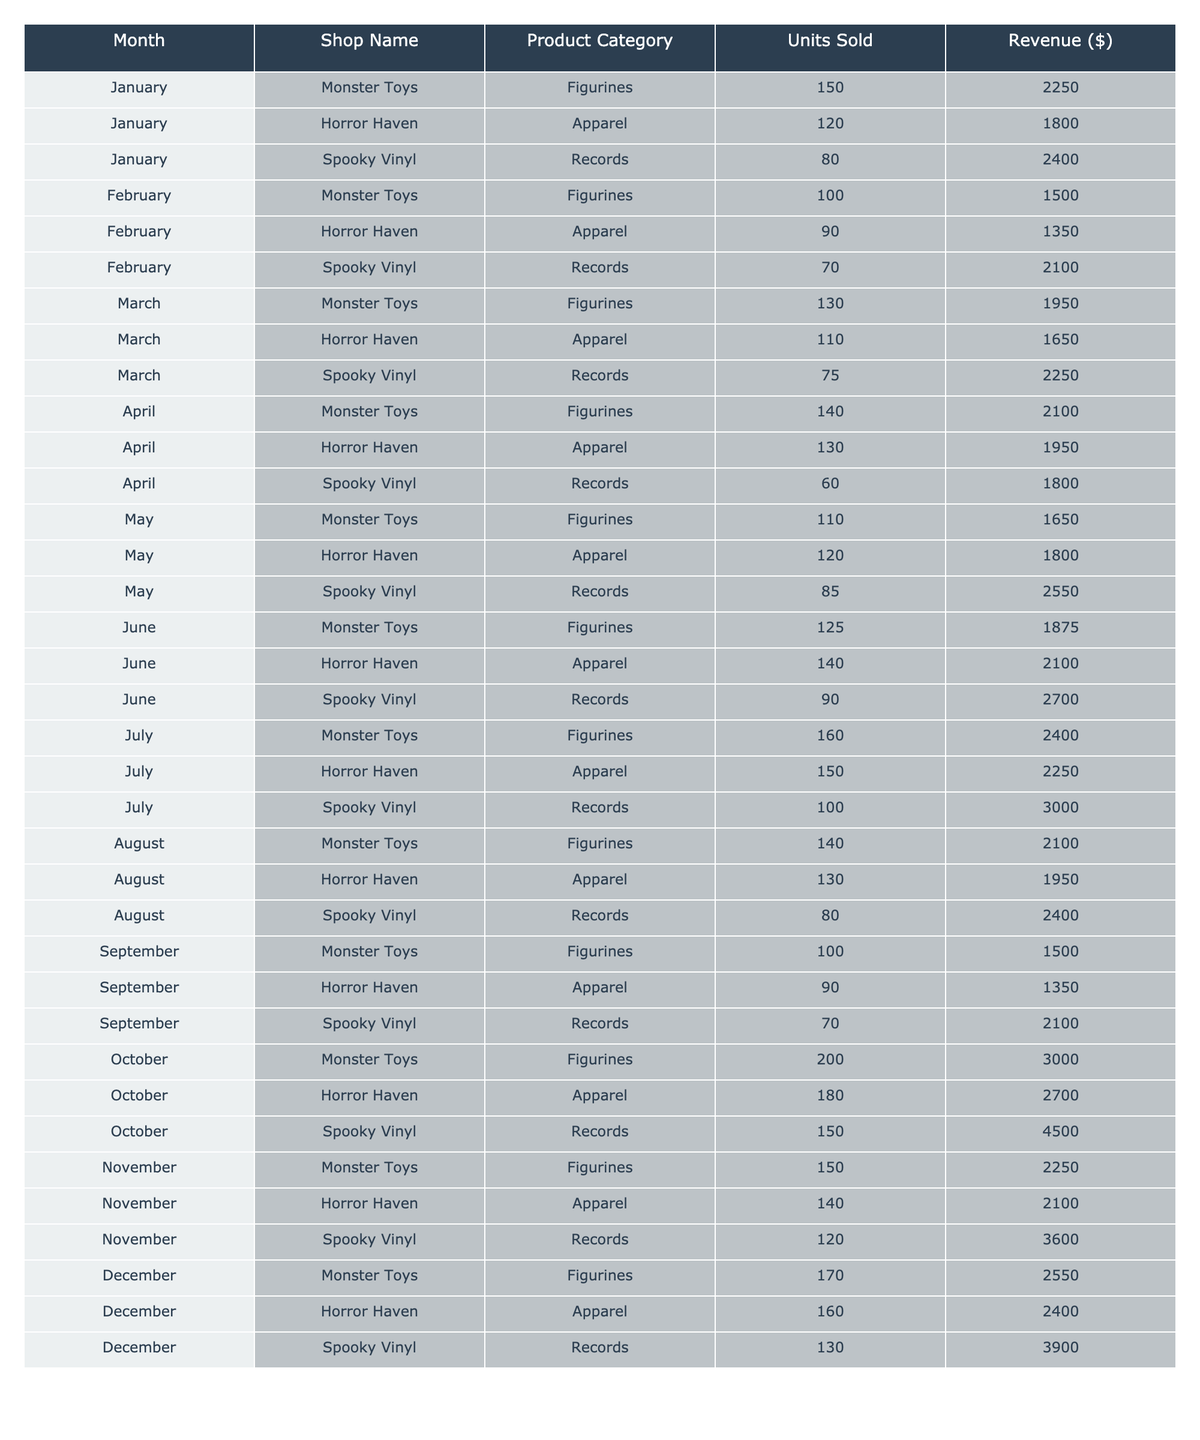What month had the highest sales revenue for Horror Haven? In October, Horror Haven sold 180 units of apparel for $2700, which is the highest revenue compared to other months.
Answer: October Which product category sold the most units in July? In July, Monster Toys sold 160 figurines, which is the highest number of units sold for any product category that month.
Answer: Figurines What was the total revenue generated by Spooky Vinyl in December? In December, Spooky Vinyl sold 130 records for $3900. Therefore, the total revenue for Spooky Vinyl that month is $3900.
Answer: $3900 What is the average number of units sold for Horror Haven's apparel across the year? The total units sold by Horror Haven for apparel are (120 + 90 + 110 + 130 + 120 + 140 + 150 + 130 + 90 + 180 + 140 + 160) = 1,560. There are 12 months, so the average is 1,560 / 12 = 130.
Answer: 130 Did Monster Toys sell more units in October compared to any other month? In October, Monster Toys sold 200 units of figurines, which is higher than any other monthly sales figures found in the table across all months.
Answer: Yes What was the total number of figurines sold by Monster Toys from January to June? Adding Monster Toys' figurines from January to June gives (150 + 100 + 130 + 140 + 110 + 125) = 755 units sold in total.
Answer: 755 Which month had the lowest sales for Spooky Vinyl's records? In September, Spooky Vinyl sold only 70 records, which is the lowest compared to all other months presented in the table.
Answer: September What was the revenue difference between the highest and lowest earning month for the Spooky Vinyl records? The highest revenue for Spooky Vinyl records was in October at $4500, and the lowest was in September at $2100. The difference is $4500 - $2100 = $2400.
Answer: $2400 Which shop had the highest sales revenue overall? By summing up the revenue across all months for each shop: Monster Toys generates total revenue of $25,275, Horror Haven generates $17,540, and Spooky Vinyl generates $21,600, leading to Monster Toys having the highest overall sales revenue.
Answer: Monster Toys Was there a month where all shops sold the same amount of revenue? Reviewing the revenue for each shop in every month shows that no month has consistent sales revenue across Monster Toys, Horror Haven, and Spooky Vinyl.
Answer: No 